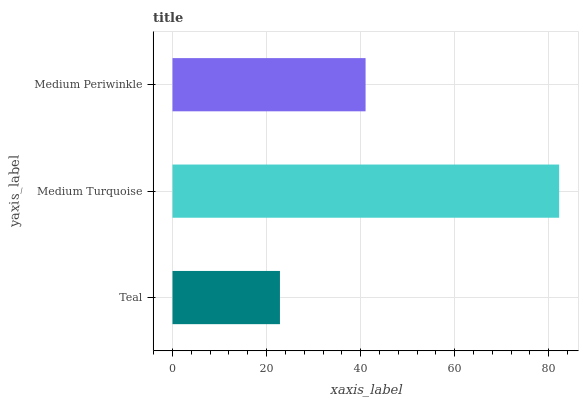Is Teal the minimum?
Answer yes or no. Yes. Is Medium Turquoise the maximum?
Answer yes or no. Yes. Is Medium Periwinkle the minimum?
Answer yes or no. No. Is Medium Periwinkle the maximum?
Answer yes or no. No. Is Medium Turquoise greater than Medium Periwinkle?
Answer yes or no. Yes. Is Medium Periwinkle less than Medium Turquoise?
Answer yes or no. Yes. Is Medium Periwinkle greater than Medium Turquoise?
Answer yes or no. No. Is Medium Turquoise less than Medium Periwinkle?
Answer yes or no. No. Is Medium Periwinkle the high median?
Answer yes or no. Yes. Is Medium Periwinkle the low median?
Answer yes or no. Yes. Is Medium Turquoise the high median?
Answer yes or no. No. Is Medium Turquoise the low median?
Answer yes or no. No. 